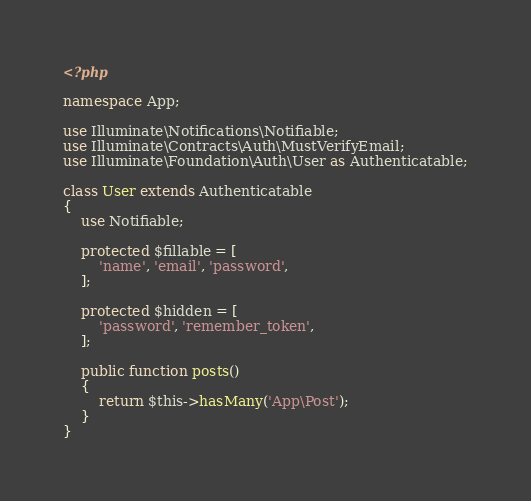<code> <loc_0><loc_0><loc_500><loc_500><_PHP_><?php

namespace App;

use Illuminate\Notifications\Notifiable;
use Illuminate\Contracts\Auth\MustVerifyEmail;
use Illuminate\Foundation\Auth\User as Authenticatable;

class User extends Authenticatable
{
    use Notifiable;

    protected $fillable = [
        'name', 'email', 'password',
    ];

    protected $hidden = [
        'password', 'remember_token',
    ];

    public function posts()
    {
        return $this->hasMany('App\Post');
    }
}
</code> 